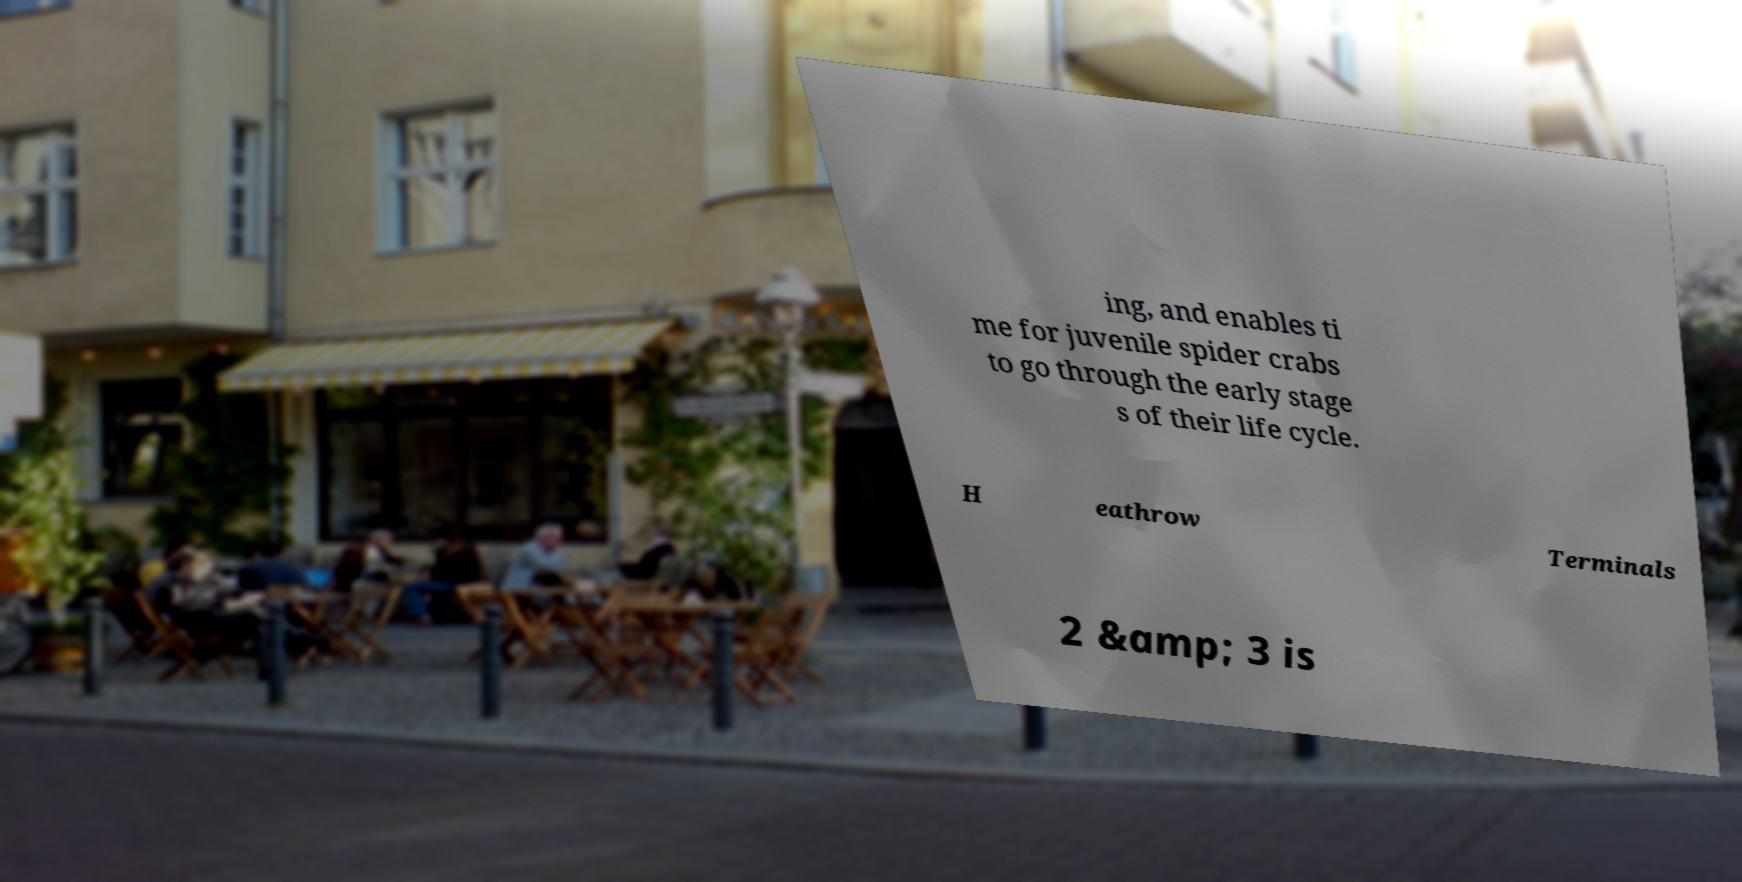Could you assist in decoding the text presented in this image and type it out clearly? ing, and enables ti me for juvenile spider crabs to go through the early stage s of their life cycle. H eathrow Terminals 2 &amp; 3 is 